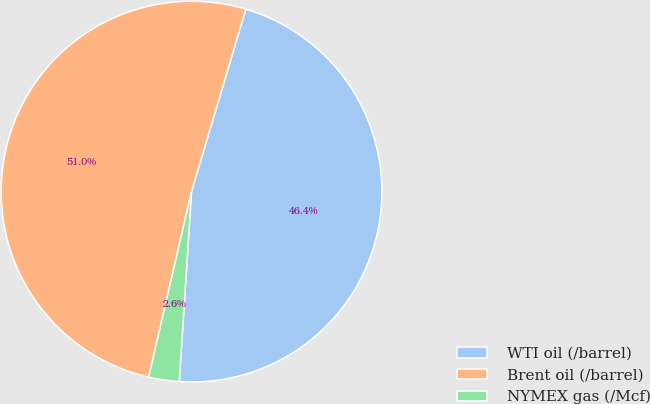<chart> <loc_0><loc_0><loc_500><loc_500><pie_chart><fcel>WTI oil (/barrel)<fcel>Brent oil (/barrel)<fcel>NYMEX gas (/Mcf)<nl><fcel>46.42%<fcel>50.99%<fcel>2.59%<nl></chart> 